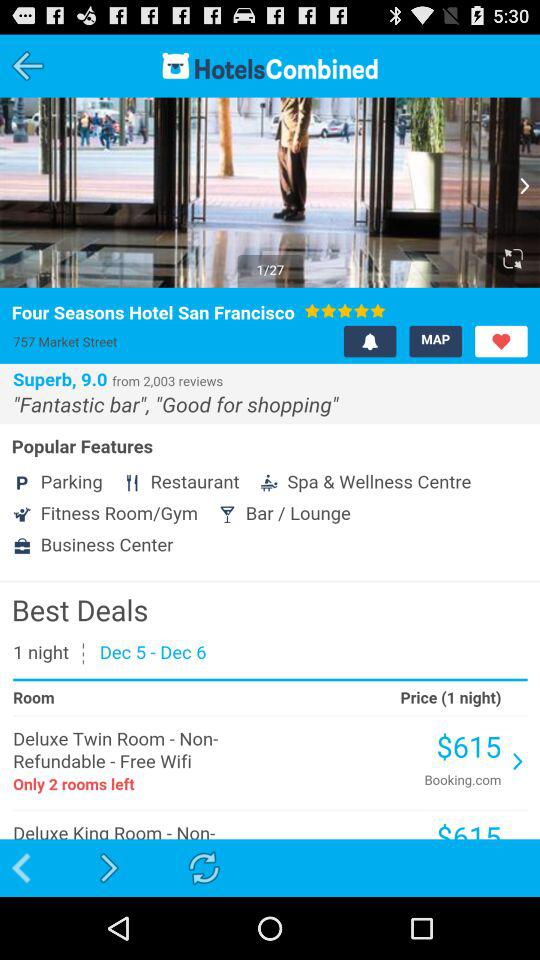What are the popular features? The popular features are "Parking", "Restaurant", "Spa & Wellness Centre", "Fitness Room/Gym", "Bar / Lounge", and "Business Center". 